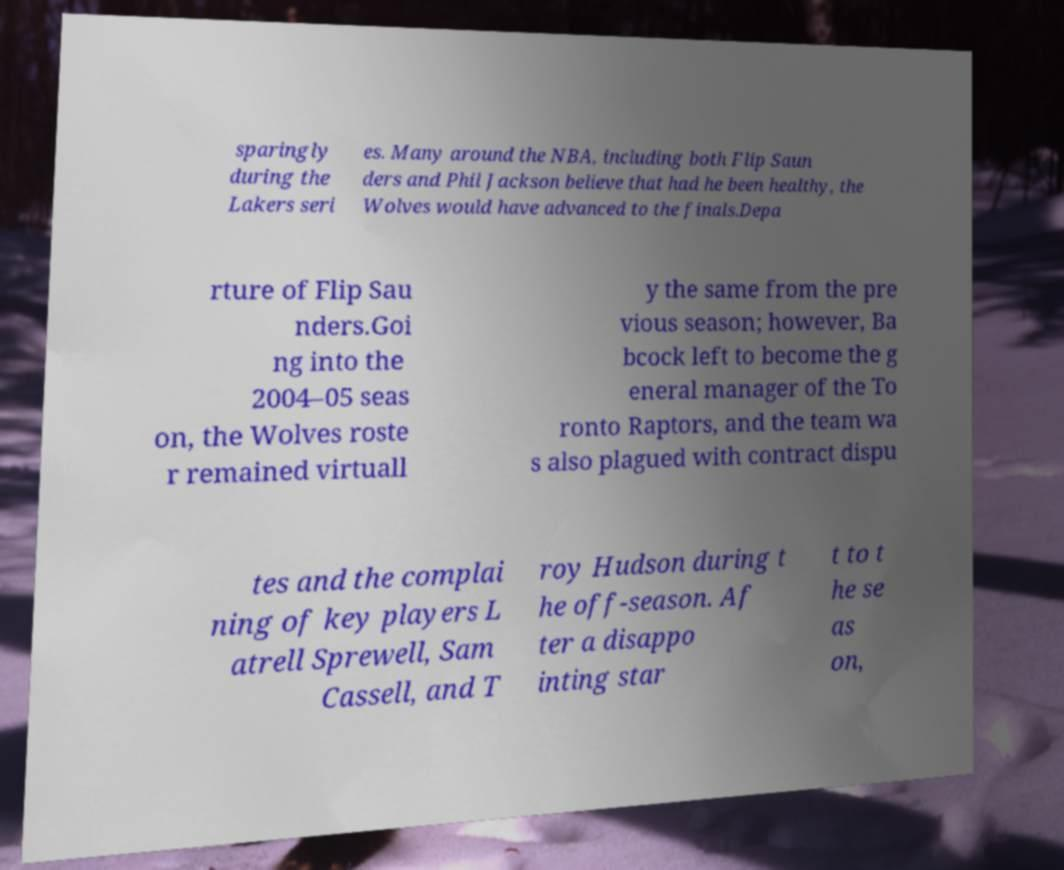Could you extract and type out the text from this image? sparingly during the Lakers seri es. Many around the NBA, including both Flip Saun ders and Phil Jackson believe that had he been healthy, the Wolves would have advanced to the finals.Depa rture of Flip Sau nders.Goi ng into the 2004–05 seas on, the Wolves roste r remained virtuall y the same from the pre vious season; however, Ba bcock left to become the g eneral manager of the To ronto Raptors, and the team wa s also plagued with contract dispu tes and the complai ning of key players L atrell Sprewell, Sam Cassell, and T roy Hudson during t he off-season. Af ter a disappo inting star t to t he se as on, 